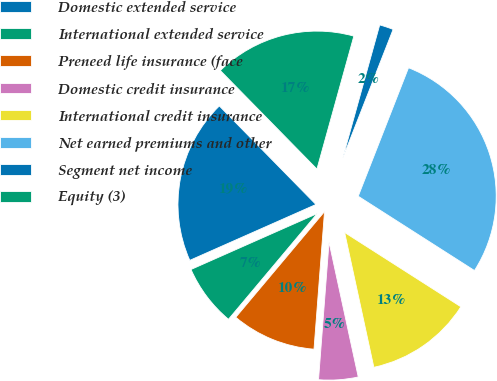Convert chart. <chart><loc_0><loc_0><loc_500><loc_500><pie_chart><fcel>Domestic extended service<fcel>International extended service<fcel>Preneed life insurance (face<fcel>Domestic credit insurance<fcel>International credit insurance<fcel>Net earned premiums and other<fcel>Segment net income<fcel>Equity (3)<nl><fcel>19.29%<fcel>7.25%<fcel>9.9%<fcel>4.61%<fcel>12.55%<fcel>28.11%<fcel>1.63%<fcel>16.65%<nl></chart> 